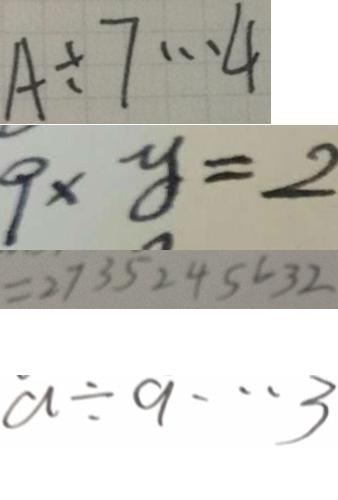<formula> <loc_0><loc_0><loc_500><loc_500>A \div 7 \cdots 4 
 9 \times y = 2 
 = 2 7 3 5 2 4 5 6 3 2 
 a \div 9 \cdots 3</formula> 